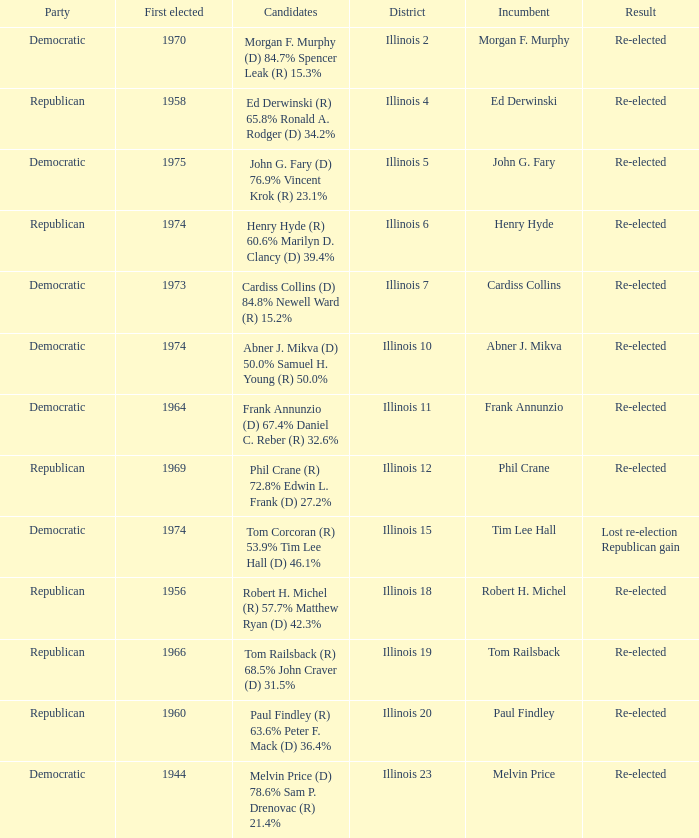Name the district for tim lee hall Illinois 15. 